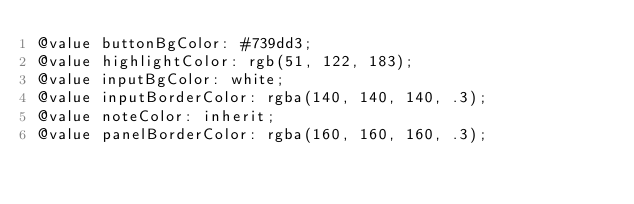<code> <loc_0><loc_0><loc_500><loc_500><_CSS_>@value buttonBgColor: #739dd3;
@value highlightColor: rgb(51, 122, 183);
@value inputBgColor: white;
@value inputBorderColor: rgba(140, 140, 140, .3);
@value noteColor: inherit;
@value panelBorderColor: rgba(160, 160, 160, .3);
</code> 